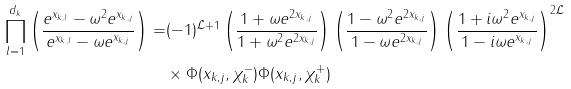Convert formula to latex. <formula><loc_0><loc_0><loc_500><loc_500>\prod _ { l = 1 } ^ { d _ { k } } \left ( \frac { e ^ { x _ { k , l } } - \omega ^ { 2 } e ^ { x _ { k , j } } } { e ^ { x _ { k , l } } - \omega e ^ { x _ { k , j } } } \right ) = & ( - 1 ) ^ { \mathcal { L } + 1 } \left ( \frac { 1 + \omega e ^ { 2 x _ { k , j } } } { 1 + \omega ^ { 2 } e ^ { 2 x _ { k , j } } } \right ) \left ( \frac { 1 - \omega ^ { 2 } e ^ { 2 x _ { k , j } } } { 1 - \omega e ^ { 2 x _ { k , j } } } \right ) \left ( \frac { 1 + i \omega ^ { 2 } e ^ { x _ { k , j } } } { 1 - i \omega e ^ { x _ { k , j } } } \right ) ^ { 2 \mathcal { L } } \\ & \times \Phi ( x _ { k , j } , \chi _ { k } ^ { - } ) \Phi ( x _ { k , j } , \chi _ { k } ^ { + } )</formula> 